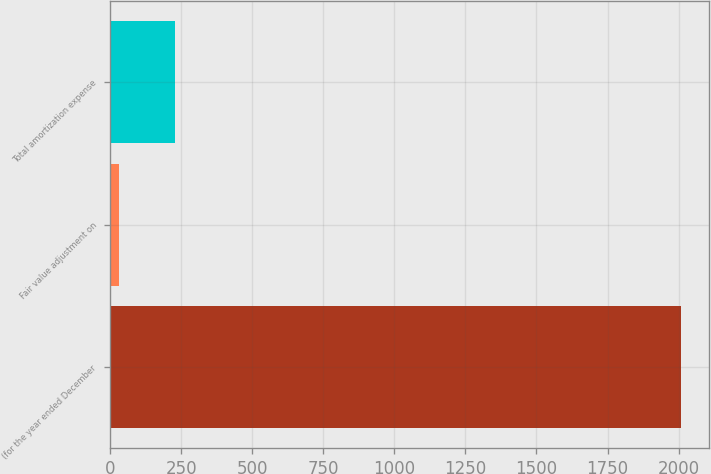Convert chart. <chart><loc_0><loc_0><loc_500><loc_500><bar_chart><fcel>(for the year ended December<fcel>Fair value adjustment on<fcel>Total amortization expense<nl><fcel>2008<fcel>30<fcel>227.8<nl></chart> 